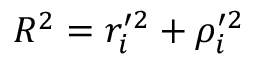Convert formula to latex. <formula><loc_0><loc_0><loc_500><loc_500>R ^ { 2 } = r _ { i } ^ { \prime 2 } + \rho _ { i } ^ { \prime 2 }</formula> 